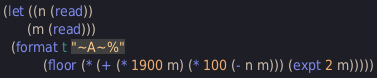Convert code to text. <code><loc_0><loc_0><loc_500><loc_500><_Lisp_>(let ((n (read))
      (m (read)))
  (format t "~A~%"
          (floor (* (+ (* 1900 m) (* 100 (- n m))) (expt 2 m)))))</code> 